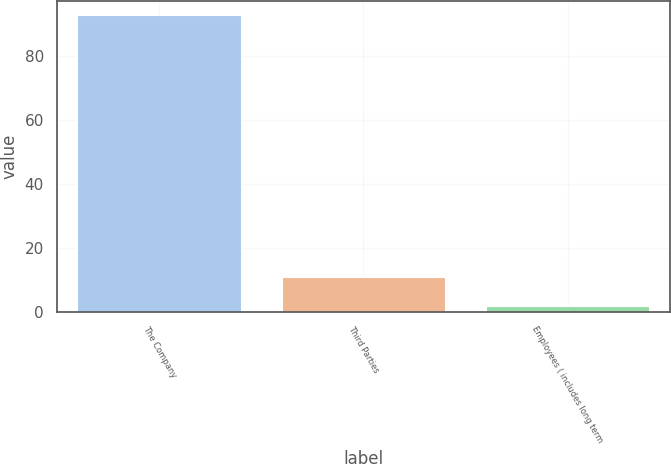Convert chart. <chart><loc_0><loc_0><loc_500><loc_500><bar_chart><fcel>The Company<fcel>Third Parties<fcel>Employees ( includes long term<nl><fcel>92.6<fcel>10.79<fcel>1.7<nl></chart> 